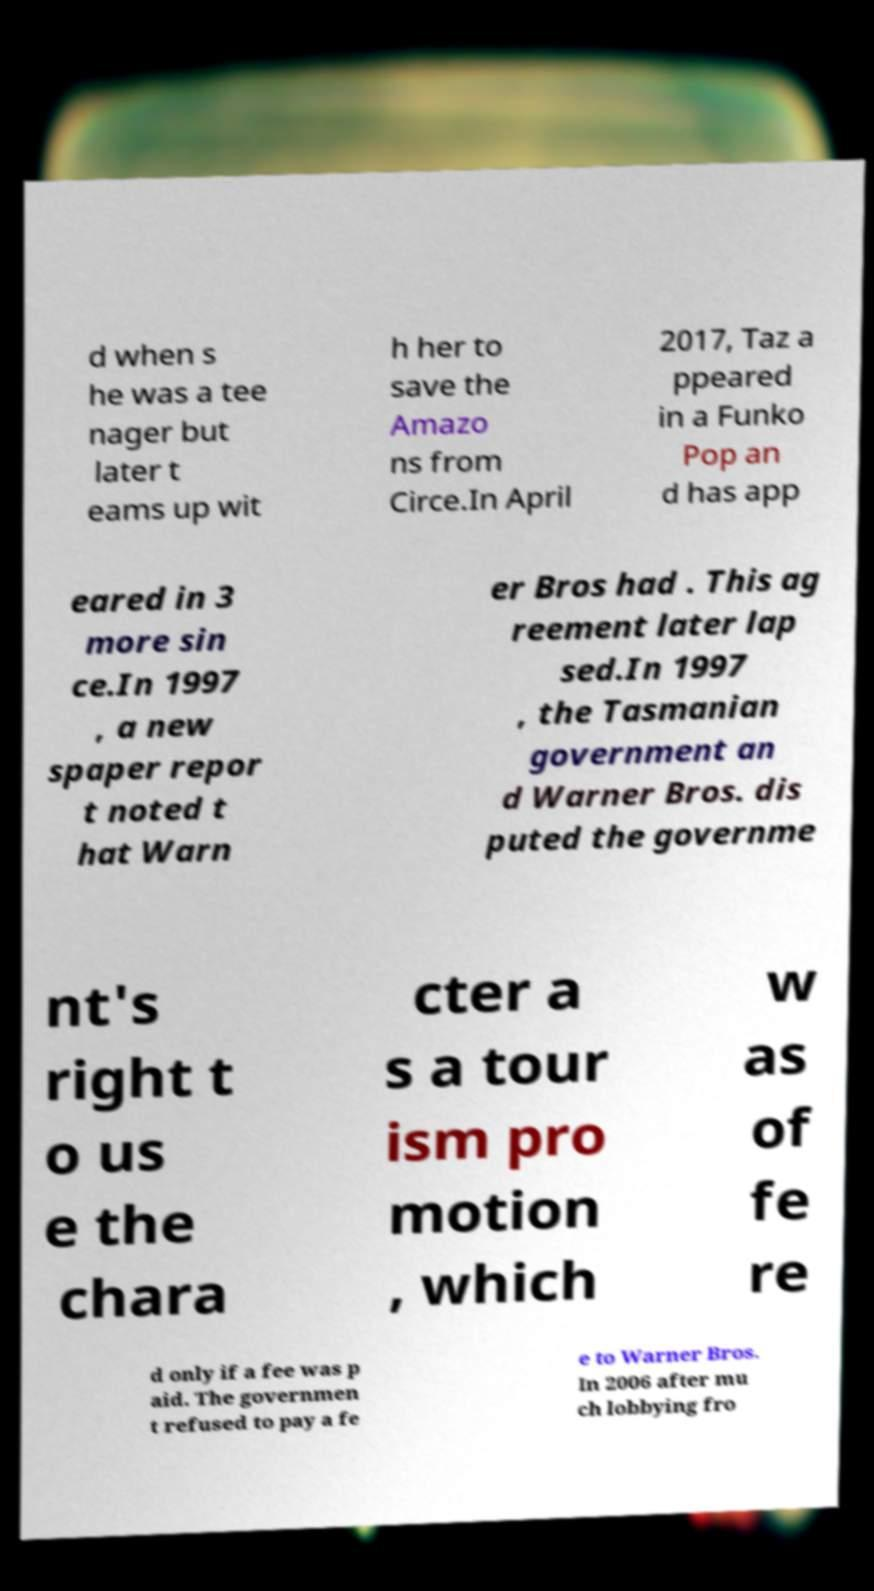There's text embedded in this image that I need extracted. Can you transcribe it verbatim? d when s he was a tee nager but later t eams up wit h her to save the Amazo ns from Circe.In April 2017, Taz a ppeared in a Funko Pop an d has app eared in 3 more sin ce.In 1997 , a new spaper repor t noted t hat Warn er Bros had . This ag reement later lap sed.In 1997 , the Tasmanian government an d Warner Bros. dis puted the governme nt's right t o us e the chara cter a s a tour ism pro motion , which w as of fe re d only if a fee was p aid. The governmen t refused to pay a fe e to Warner Bros. In 2006 after mu ch lobbying fro 